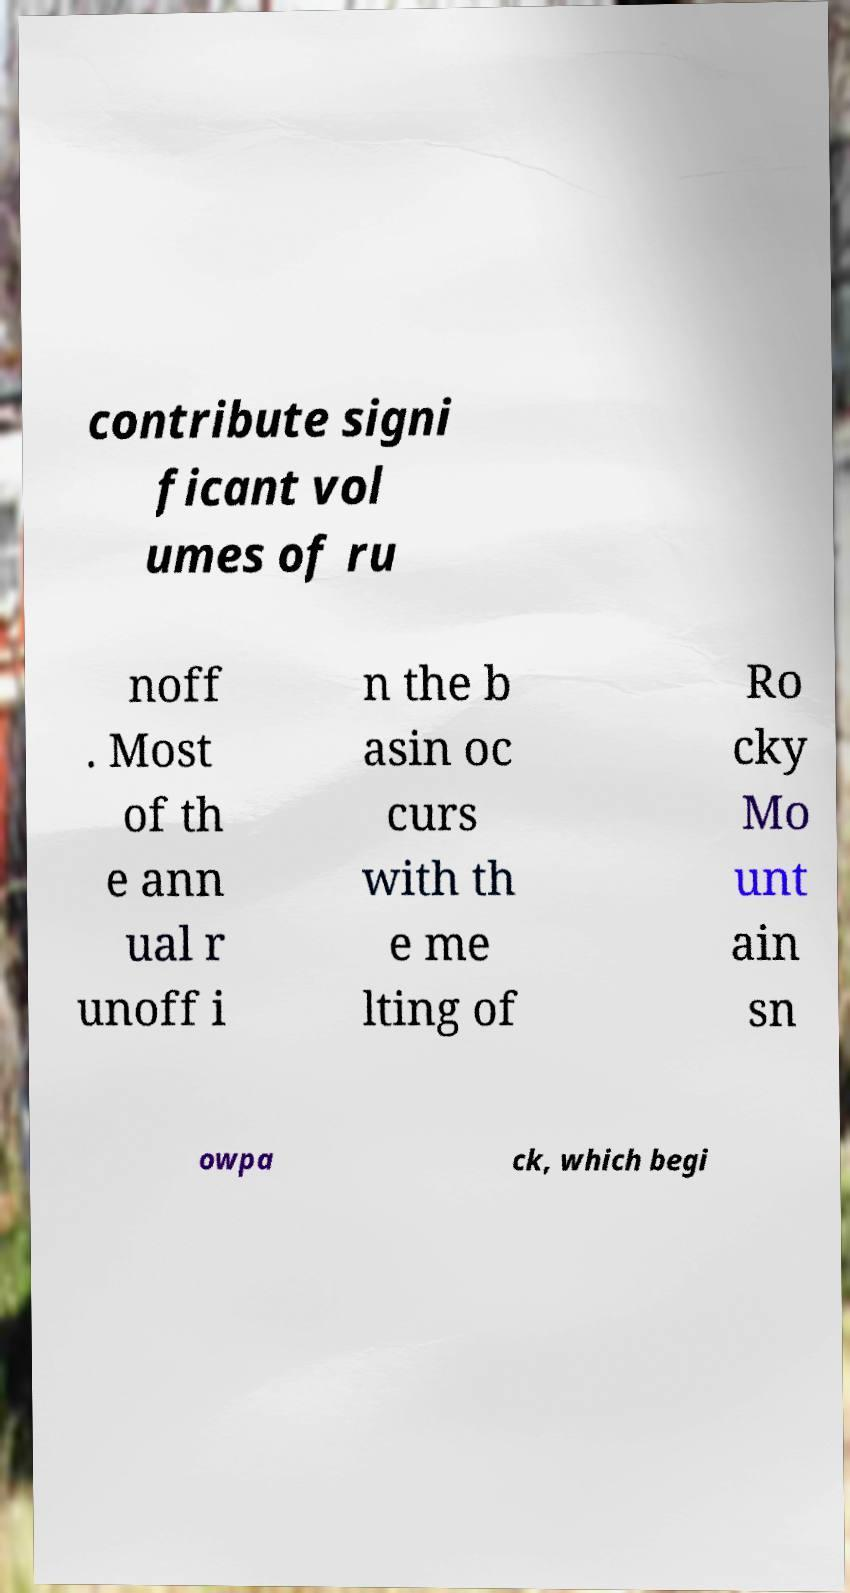Can you read and provide the text displayed in the image?This photo seems to have some interesting text. Can you extract and type it out for me? contribute signi ficant vol umes of ru noff . Most of th e ann ual r unoff i n the b asin oc curs with th e me lting of Ro cky Mo unt ain sn owpa ck, which begi 